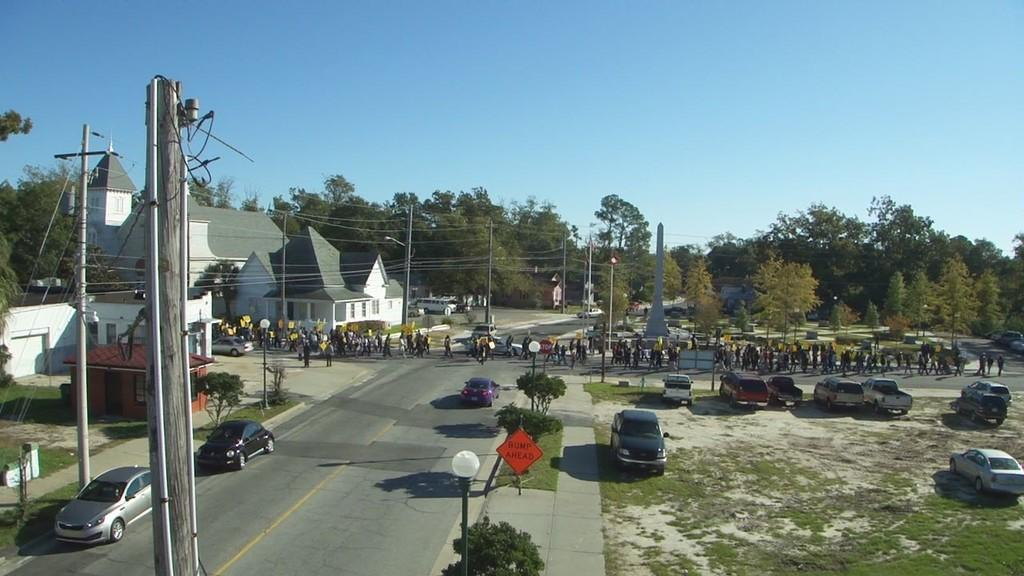What type of structures can be seen in the image? There are houses in the image. What are the vertical objects in the image? There are poles and light poles in the image. What type of vegetation is present in the image? There are trees in the image. What part of the natural environment is visible in the image? The sky is visible in the image. What type of surface is present in the image? There is grass in the image. What is happening on the road in the image? People and vehicles are present on the road in the image. Can you read the writing on the ground in the image? There is no writing present on the ground in the image. How many feet are visible on the people in the image? The image does not show the feet of the people present on the road. 